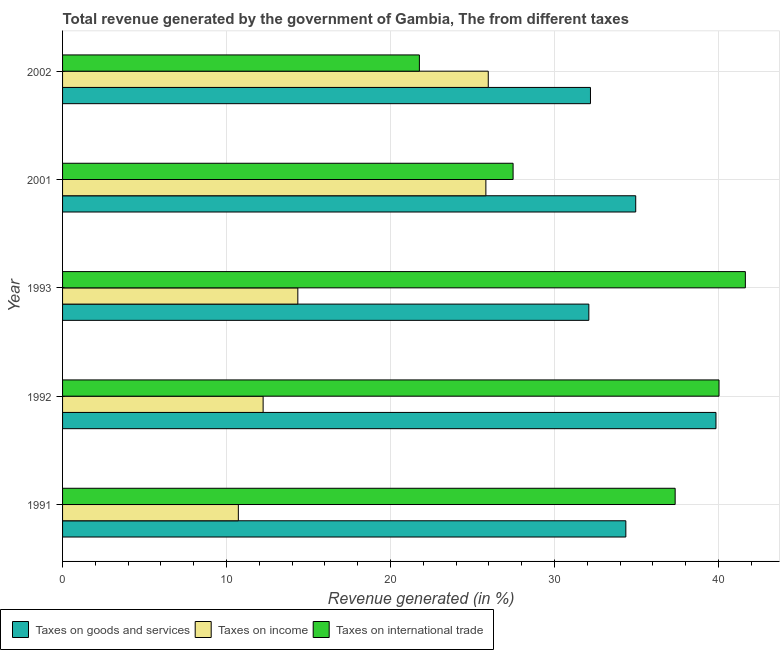How many different coloured bars are there?
Ensure brevity in your answer.  3. How many groups of bars are there?
Your answer should be compact. 5. Are the number of bars per tick equal to the number of legend labels?
Your response must be concise. Yes. How many bars are there on the 4th tick from the top?
Your response must be concise. 3. What is the label of the 1st group of bars from the top?
Ensure brevity in your answer.  2002. What is the percentage of revenue generated by tax on international trade in 2001?
Provide a short and direct response. 27.48. Across all years, what is the maximum percentage of revenue generated by tax on international trade?
Provide a succinct answer. 41.64. Across all years, what is the minimum percentage of revenue generated by taxes on goods and services?
Provide a short and direct response. 32.1. What is the total percentage of revenue generated by taxes on income in the graph?
Give a very brief answer. 89.08. What is the difference between the percentage of revenue generated by tax on international trade in 1992 and that in 2002?
Ensure brevity in your answer.  18.27. What is the difference between the percentage of revenue generated by taxes on goods and services in 2001 and the percentage of revenue generated by tax on international trade in 1993?
Your response must be concise. -6.69. What is the average percentage of revenue generated by taxes on income per year?
Keep it short and to the point. 17.82. In the year 1991, what is the difference between the percentage of revenue generated by tax on international trade and percentage of revenue generated by taxes on income?
Give a very brief answer. 26.64. In how many years, is the percentage of revenue generated by tax on international trade greater than 26 %?
Offer a terse response. 4. What is the ratio of the percentage of revenue generated by taxes on income in 1992 to that in 2001?
Provide a succinct answer. 0.47. Is the difference between the percentage of revenue generated by taxes on goods and services in 1992 and 1993 greater than the difference between the percentage of revenue generated by taxes on income in 1992 and 1993?
Give a very brief answer. Yes. What is the difference between the highest and the second highest percentage of revenue generated by tax on international trade?
Give a very brief answer. 1.61. What is the difference between the highest and the lowest percentage of revenue generated by taxes on goods and services?
Your answer should be compact. 7.75. Is the sum of the percentage of revenue generated by tax on international trade in 1992 and 1993 greater than the maximum percentage of revenue generated by taxes on goods and services across all years?
Provide a succinct answer. Yes. What does the 3rd bar from the top in 1992 represents?
Your response must be concise. Taxes on goods and services. What does the 3rd bar from the bottom in 1992 represents?
Provide a short and direct response. Taxes on international trade. How many bars are there?
Keep it short and to the point. 15. How many years are there in the graph?
Your answer should be compact. 5. What is the difference between two consecutive major ticks on the X-axis?
Make the answer very short. 10. Are the values on the major ticks of X-axis written in scientific E-notation?
Make the answer very short. No. Does the graph contain grids?
Offer a terse response. Yes. How many legend labels are there?
Your response must be concise. 3. How are the legend labels stacked?
Ensure brevity in your answer.  Horizontal. What is the title of the graph?
Offer a very short reply. Total revenue generated by the government of Gambia, The from different taxes. Does "Profit Tax" appear as one of the legend labels in the graph?
Ensure brevity in your answer.  No. What is the label or title of the X-axis?
Your answer should be very brief. Revenue generated (in %). What is the Revenue generated (in %) in Taxes on goods and services in 1991?
Your answer should be very brief. 34.35. What is the Revenue generated (in %) in Taxes on income in 1991?
Give a very brief answer. 10.72. What is the Revenue generated (in %) in Taxes on international trade in 1991?
Make the answer very short. 37.36. What is the Revenue generated (in %) of Taxes on goods and services in 1992?
Give a very brief answer. 39.85. What is the Revenue generated (in %) of Taxes on income in 1992?
Your answer should be compact. 12.23. What is the Revenue generated (in %) of Taxes on international trade in 1992?
Provide a short and direct response. 40.03. What is the Revenue generated (in %) of Taxes on goods and services in 1993?
Your answer should be very brief. 32.1. What is the Revenue generated (in %) of Taxes on income in 1993?
Make the answer very short. 14.35. What is the Revenue generated (in %) of Taxes on international trade in 1993?
Your answer should be very brief. 41.64. What is the Revenue generated (in %) in Taxes on goods and services in 2001?
Your answer should be very brief. 34.95. What is the Revenue generated (in %) in Taxes on income in 2001?
Ensure brevity in your answer.  25.82. What is the Revenue generated (in %) of Taxes on international trade in 2001?
Your answer should be very brief. 27.48. What is the Revenue generated (in %) of Taxes on goods and services in 2002?
Offer a very short reply. 32.19. What is the Revenue generated (in %) in Taxes on income in 2002?
Give a very brief answer. 25.96. What is the Revenue generated (in %) of Taxes on international trade in 2002?
Keep it short and to the point. 21.76. Across all years, what is the maximum Revenue generated (in %) of Taxes on goods and services?
Your response must be concise. 39.85. Across all years, what is the maximum Revenue generated (in %) of Taxes on income?
Make the answer very short. 25.96. Across all years, what is the maximum Revenue generated (in %) in Taxes on international trade?
Your answer should be compact. 41.64. Across all years, what is the minimum Revenue generated (in %) in Taxes on goods and services?
Provide a succinct answer. 32.1. Across all years, what is the minimum Revenue generated (in %) of Taxes on income?
Provide a succinct answer. 10.72. Across all years, what is the minimum Revenue generated (in %) of Taxes on international trade?
Make the answer very short. 21.76. What is the total Revenue generated (in %) in Taxes on goods and services in the graph?
Provide a succinct answer. 173.44. What is the total Revenue generated (in %) of Taxes on income in the graph?
Provide a short and direct response. 89.08. What is the total Revenue generated (in %) in Taxes on international trade in the graph?
Keep it short and to the point. 168.27. What is the difference between the Revenue generated (in %) in Taxes on goods and services in 1991 and that in 1992?
Provide a succinct answer. -5.5. What is the difference between the Revenue generated (in %) in Taxes on income in 1991 and that in 1992?
Your response must be concise. -1.51. What is the difference between the Revenue generated (in %) of Taxes on international trade in 1991 and that in 1992?
Keep it short and to the point. -2.67. What is the difference between the Revenue generated (in %) in Taxes on goods and services in 1991 and that in 1993?
Your answer should be compact. 2.26. What is the difference between the Revenue generated (in %) of Taxes on income in 1991 and that in 1993?
Ensure brevity in your answer.  -3.63. What is the difference between the Revenue generated (in %) of Taxes on international trade in 1991 and that in 1993?
Offer a very short reply. -4.28. What is the difference between the Revenue generated (in %) in Taxes on goods and services in 1991 and that in 2001?
Your response must be concise. -0.6. What is the difference between the Revenue generated (in %) in Taxes on income in 1991 and that in 2001?
Make the answer very short. -15.1. What is the difference between the Revenue generated (in %) of Taxes on international trade in 1991 and that in 2001?
Your answer should be very brief. 9.88. What is the difference between the Revenue generated (in %) of Taxes on goods and services in 1991 and that in 2002?
Your response must be concise. 2.16. What is the difference between the Revenue generated (in %) of Taxes on income in 1991 and that in 2002?
Your answer should be compact. -15.24. What is the difference between the Revenue generated (in %) in Taxes on international trade in 1991 and that in 2002?
Provide a succinct answer. 15.6. What is the difference between the Revenue generated (in %) in Taxes on goods and services in 1992 and that in 1993?
Your answer should be very brief. 7.75. What is the difference between the Revenue generated (in %) in Taxes on income in 1992 and that in 1993?
Ensure brevity in your answer.  -2.12. What is the difference between the Revenue generated (in %) in Taxes on international trade in 1992 and that in 1993?
Make the answer very short. -1.61. What is the difference between the Revenue generated (in %) of Taxes on goods and services in 1992 and that in 2001?
Provide a succinct answer. 4.89. What is the difference between the Revenue generated (in %) in Taxes on income in 1992 and that in 2001?
Your answer should be compact. -13.59. What is the difference between the Revenue generated (in %) of Taxes on international trade in 1992 and that in 2001?
Ensure brevity in your answer.  12.56. What is the difference between the Revenue generated (in %) in Taxes on goods and services in 1992 and that in 2002?
Ensure brevity in your answer.  7.65. What is the difference between the Revenue generated (in %) in Taxes on income in 1992 and that in 2002?
Provide a succinct answer. -13.73. What is the difference between the Revenue generated (in %) of Taxes on international trade in 1992 and that in 2002?
Keep it short and to the point. 18.27. What is the difference between the Revenue generated (in %) in Taxes on goods and services in 1993 and that in 2001?
Give a very brief answer. -2.86. What is the difference between the Revenue generated (in %) in Taxes on income in 1993 and that in 2001?
Provide a succinct answer. -11.47. What is the difference between the Revenue generated (in %) of Taxes on international trade in 1993 and that in 2001?
Give a very brief answer. 14.16. What is the difference between the Revenue generated (in %) in Taxes on goods and services in 1993 and that in 2002?
Your answer should be very brief. -0.1. What is the difference between the Revenue generated (in %) of Taxes on income in 1993 and that in 2002?
Provide a succinct answer. -11.61. What is the difference between the Revenue generated (in %) of Taxes on international trade in 1993 and that in 2002?
Your answer should be compact. 19.88. What is the difference between the Revenue generated (in %) of Taxes on goods and services in 2001 and that in 2002?
Give a very brief answer. 2.76. What is the difference between the Revenue generated (in %) in Taxes on income in 2001 and that in 2002?
Provide a succinct answer. -0.15. What is the difference between the Revenue generated (in %) of Taxes on international trade in 2001 and that in 2002?
Ensure brevity in your answer.  5.71. What is the difference between the Revenue generated (in %) in Taxes on goods and services in 1991 and the Revenue generated (in %) in Taxes on income in 1992?
Offer a very short reply. 22.12. What is the difference between the Revenue generated (in %) of Taxes on goods and services in 1991 and the Revenue generated (in %) of Taxes on international trade in 1992?
Keep it short and to the point. -5.68. What is the difference between the Revenue generated (in %) in Taxes on income in 1991 and the Revenue generated (in %) in Taxes on international trade in 1992?
Provide a succinct answer. -29.31. What is the difference between the Revenue generated (in %) of Taxes on goods and services in 1991 and the Revenue generated (in %) of Taxes on income in 1993?
Offer a terse response. 20. What is the difference between the Revenue generated (in %) in Taxes on goods and services in 1991 and the Revenue generated (in %) in Taxes on international trade in 1993?
Ensure brevity in your answer.  -7.29. What is the difference between the Revenue generated (in %) in Taxes on income in 1991 and the Revenue generated (in %) in Taxes on international trade in 1993?
Your response must be concise. -30.92. What is the difference between the Revenue generated (in %) of Taxes on goods and services in 1991 and the Revenue generated (in %) of Taxes on income in 2001?
Give a very brief answer. 8.54. What is the difference between the Revenue generated (in %) in Taxes on goods and services in 1991 and the Revenue generated (in %) in Taxes on international trade in 2001?
Keep it short and to the point. 6.88. What is the difference between the Revenue generated (in %) of Taxes on income in 1991 and the Revenue generated (in %) of Taxes on international trade in 2001?
Give a very brief answer. -16.76. What is the difference between the Revenue generated (in %) in Taxes on goods and services in 1991 and the Revenue generated (in %) in Taxes on income in 2002?
Your response must be concise. 8.39. What is the difference between the Revenue generated (in %) of Taxes on goods and services in 1991 and the Revenue generated (in %) of Taxes on international trade in 2002?
Give a very brief answer. 12.59. What is the difference between the Revenue generated (in %) of Taxes on income in 1991 and the Revenue generated (in %) of Taxes on international trade in 2002?
Make the answer very short. -11.04. What is the difference between the Revenue generated (in %) in Taxes on goods and services in 1992 and the Revenue generated (in %) in Taxes on income in 1993?
Provide a short and direct response. 25.5. What is the difference between the Revenue generated (in %) in Taxes on goods and services in 1992 and the Revenue generated (in %) in Taxes on international trade in 1993?
Give a very brief answer. -1.79. What is the difference between the Revenue generated (in %) in Taxes on income in 1992 and the Revenue generated (in %) in Taxes on international trade in 1993?
Your answer should be very brief. -29.41. What is the difference between the Revenue generated (in %) of Taxes on goods and services in 1992 and the Revenue generated (in %) of Taxes on income in 2001?
Your response must be concise. 14.03. What is the difference between the Revenue generated (in %) of Taxes on goods and services in 1992 and the Revenue generated (in %) of Taxes on international trade in 2001?
Your response must be concise. 12.37. What is the difference between the Revenue generated (in %) in Taxes on income in 1992 and the Revenue generated (in %) in Taxes on international trade in 2001?
Give a very brief answer. -15.24. What is the difference between the Revenue generated (in %) of Taxes on goods and services in 1992 and the Revenue generated (in %) of Taxes on income in 2002?
Provide a succinct answer. 13.89. What is the difference between the Revenue generated (in %) of Taxes on goods and services in 1992 and the Revenue generated (in %) of Taxes on international trade in 2002?
Provide a succinct answer. 18.09. What is the difference between the Revenue generated (in %) in Taxes on income in 1992 and the Revenue generated (in %) in Taxes on international trade in 2002?
Give a very brief answer. -9.53. What is the difference between the Revenue generated (in %) in Taxes on goods and services in 1993 and the Revenue generated (in %) in Taxes on income in 2001?
Make the answer very short. 6.28. What is the difference between the Revenue generated (in %) in Taxes on goods and services in 1993 and the Revenue generated (in %) in Taxes on international trade in 2001?
Your response must be concise. 4.62. What is the difference between the Revenue generated (in %) of Taxes on income in 1993 and the Revenue generated (in %) of Taxes on international trade in 2001?
Keep it short and to the point. -13.13. What is the difference between the Revenue generated (in %) of Taxes on goods and services in 1993 and the Revenue generated (in %) of Taxes on income in 2002?
Make the answer very short. 6.13. What is the difference between the Revenue generated (in %) of Taxes on goods and services in 1993 and the Revenue generated (in %) of Taxes on international trade in 2002?
Your response must be concise. 10.33. What is the difference between the Revenue generated (in %) of Taxes on income in 1993 and the Revenue generated (in %) of Taxes on international trade in 2002?
Provide a succinct answer. -7.41. What is the difference between the Revenue generated (in %) of Taxes on goods and services in 2001 and the Revenue generated (in %) of Taxes on income in 2002?
Offer a terse response. 8.99. What is the difference between the Revenue generated (in %) in Taxes on goods and services in 2001 and the Revenue generated (in %) in Taxes on international trade in 2002?
Provide a short and direct response. 13.19. What is the difference between the Revenue generated (in %) of Taxes on income in 2001 and the Revenue generated (in %) of Taxes on international trade in 2002?
Your response must be concise. 4.05. What is the average Revenue generated (in %) in Taxes on goods and services per year?
Provide a short and direct response. 34.69. What is the average Revenue generated (in %) in Taxes on income per year?
Make the answer very short. 17.82. What is the average Revenue generated (in %) of Taxes on international trade per year?
Offer a very short reply. 33.65. In the year 1991, what is the difference between the Revenue generated (in %) of Taxes on goods and services and Revenue generated (in %) of Taxes on income?
Keep it short and to the point. 23.63. In the year 1991, what is the difference between the Revenue generated (in %) in Taxes on goods and services and Revenue generated (in %) in Taxes on international trade?
Offer a terse response. -3.01. In the year 1991, what is the difference between the Revenue generated (in %) of Taxes on income and Revenue generated (in %) of Taxes on international trade?
Offer a very short reply. -26.64. In the year 1992, what is the difference between the Revenue generated (in %) of Taxes on goods and services and Revenue generated (in %) of Taxes on income?
Ensure brevity in your answer.  27.62. In the year 1992, what is the difference between the Revenue generated (in %) of Taxes on goods and services and Revenue generated (in %) of Taxes on international trade?
Your answer should be compact. -0.19. In the year 1992, what is the difference between the Revenue generated (in %) of Taxes on income and Revenue generated (in %) of Taxes on international trade?
Offer a very short reply. -27.8. In the year 1993, what is the difference between the Revenue generated (in %) of Taxes on goods and services and Revenue generated (in %) of Taxes on income?
Your answer should be very brief. 17.75. In the year 1993, what is the difference between the Revenue generated (in %) of Taxes on goods and services and Revenue generated (in %) of Taxes on international trade?
Your answer should be very brief. -9.54. In the year 1993, what is the difference between the Revenue generated (in %) in Taxes on income and Revenue generated (in %) in Taxes on international trade?
Offer a terse response. -27.29. In the year 2001, what is the difference between the Revenue generated (in %) in Taxes on goods and services and Revenue generated (in %) in Taxes on income?
Offer a very short reply. 9.14. In the year 2001, what is the difference between the Revenue generated (in %) in Taxes on goods and services and Revenue generated (in %) in Taxes on international trade?
Your response must be concise. 7.48. In the year 2001, what is the difference between the Revenue generated (in %) of Taxes on income and Revenue generated (in %) of Taxes on international trade?
Offer a very short reply. -1.66. In the year 2002, what is the difference between the Revenue generated (in %) of Taxes on goods and services and Revenue generated (in %) of Taxes on income?
Your response must be concise. 6.23. In the year 2002, what is the difference between the Revenue generated (in %) in Taxes on goods and services and Revenue generated (in %) in Taxes on international trade?
Keep it short and to the point. 10.43. In the year 2002, what is the difference between the Revenue generated (in %) in Taxes on income and Revenue generated (in %) in Taxes on international trade?
Keep it short and to the point. 4.2. What is the ratio of the Revenue generated (in %) in Taxes on goods and services in 1991 to that in 1992?
Provide a short and direct response. 0.86. What is the ratio of the Revenue generated (in %) of Taxes on income in 1991 to that in 1992?
Provide a succinct answer. 0.88. What is the ratio of the Revenue generated (in %) in Taxes on international trade in 1991 to that in 1992?
Offer a terse response. 0.93. What is the ratio of the Revenue generated (in %) of Taxes on goods and services in 1991 to that in 1993?
Ensure brevity in your answer.  1.07. What is the ratio of the Revenue generated (in %) in Taxes on income in 1991 to that in 1993?
Provide a short and direct response. 0.75. What is the ratio of the Revenue generated (in %) in Taxes on international trade in 1991 to that in 1993?
Provide a succinct answer. 0.9. What is the ratio of the Revenue generated (in %) of Taxes on goods and services in 1991 to that in 2001?
Ensure brevity in your answer.  0.98. What is the ratio of the Revenue generated (in %) of Taxes on income in 1991 to that in 2001?
Make the answer very short. 0.42. What is the ratio of the Revenue generated (in %) of Taxes on international trade in 1991 to that in 2001?
Offer a terse response. 1.36. What is the ratio of the Revenue generated (in %) in Taxes on goods and services in 1991 to that in 2002?
Offer a very short reply. 1.07. What is the ratio of the Revenue generated (in %) in Taxes on income in 1991 to that in 2002?
Your response must be concise. 0.41. What is the ratio of the Revenue generated (in %) of Taxes on international trade in 1991 to that in 2002?
Keep it short and to the point. 1.72. What is the ratio of the Revenue generated (in %) of Taxes on goods and services in 1992 to that in 1993?
Keep it short and to the point. 1.24. What is the ratio of the Revenue generated (in %) in Taxes on income in 1992 to that in 1993?
Provide a succinct answer. 0.85. What is the ratio of the Revenue generated (in %) in Taxes on international trade in 1992 to that in 1993?
Your answer should be very brief. 0.96. What is the ratio of the Revenue generated (in %) of Taxes on goods and services in 1992 to that in 2001?
Give a very brief answer. 1.14. What is the ratio of the Revenue generated (in %) in Taxes on income in 1992 to that in 2001?
Make the answer very short. 0.47. What is the ratio of the Revenue generated (in %) of Taxes on international trade in 1992 to that in 2001?
Your answer should be very brief. 1.46. What is the ratio of the Revenue generated (in %) in Taxes on goods and services in 1992 to that in 2002?
Offer a very short reply. 1.24. What is the ratio of the Revenue generated (in %) in Taxes on income in 1992 to that in 2002?
Your answer should be very brief. 0.47. What is the ratio of the Revenue generated (in %) of Taxes on international trade in 1992 to that in 2002?
Provide a succinct answer. 1.84. What is the ratio of the Revenue generated (in %) of Taxes on goods and services in 1993 to that in 2001?
Keep it short and to the point. 0.92. What is the ratio of the Revenue generated (in %) in Taxes on income in 1993 to that in 2001?
Make the answer very short. 0.56. What is the ratio of the Revenue generated (in %) of Taxes on international trade in 1993 to that in 2001?
Provide a succinct answer. 1.52. What is the ratio of the Revenue generated (in %) of Taxes on income in 1993 to that in 2002?
Offer a very short reply. 0.55. What is the ratio of the Revenue generated (in %) in Taxes on international trade in 1993 to that in 2002?
Your answer should be compact. 1.91. What is the ratio of the Revenue generated (in %) of Taxes on goods and services in 2001 to that in 2002?
Offer a very short reply. 1.09. What is the ratio of the Revenue generated (in %) in Taxes on international trade in 2001 to that in 2002?
Make the answer very short. 1.26. What is the difference between the highest and the second highest Revenue generated (in %) of Taxes on goods and services?
Provide a succinct answer. 4.89. What is the difference between the highest and the second highest Revenue generated (in %) of Taxes on income?
Your answer should be very brief. 0.15. What is the difference between the highest and the second highest Revenue generated (in %) in Taxes on international trade?
Your answer should be very brief. 1.61. What is the difference between the highest and the lowest Revenue generated (in %) of Taxes on goods and services?
Keep it short and to the point. 7.75. What is the difference between the highest and the lowest Revenue generated (in %) in Taxes on income?
Give a very brief answer. 15.24. What is the difference between the highest and the lowest Revenue generated (in %) in Taxes on international trade?
Offer a terse response. 19.88. 